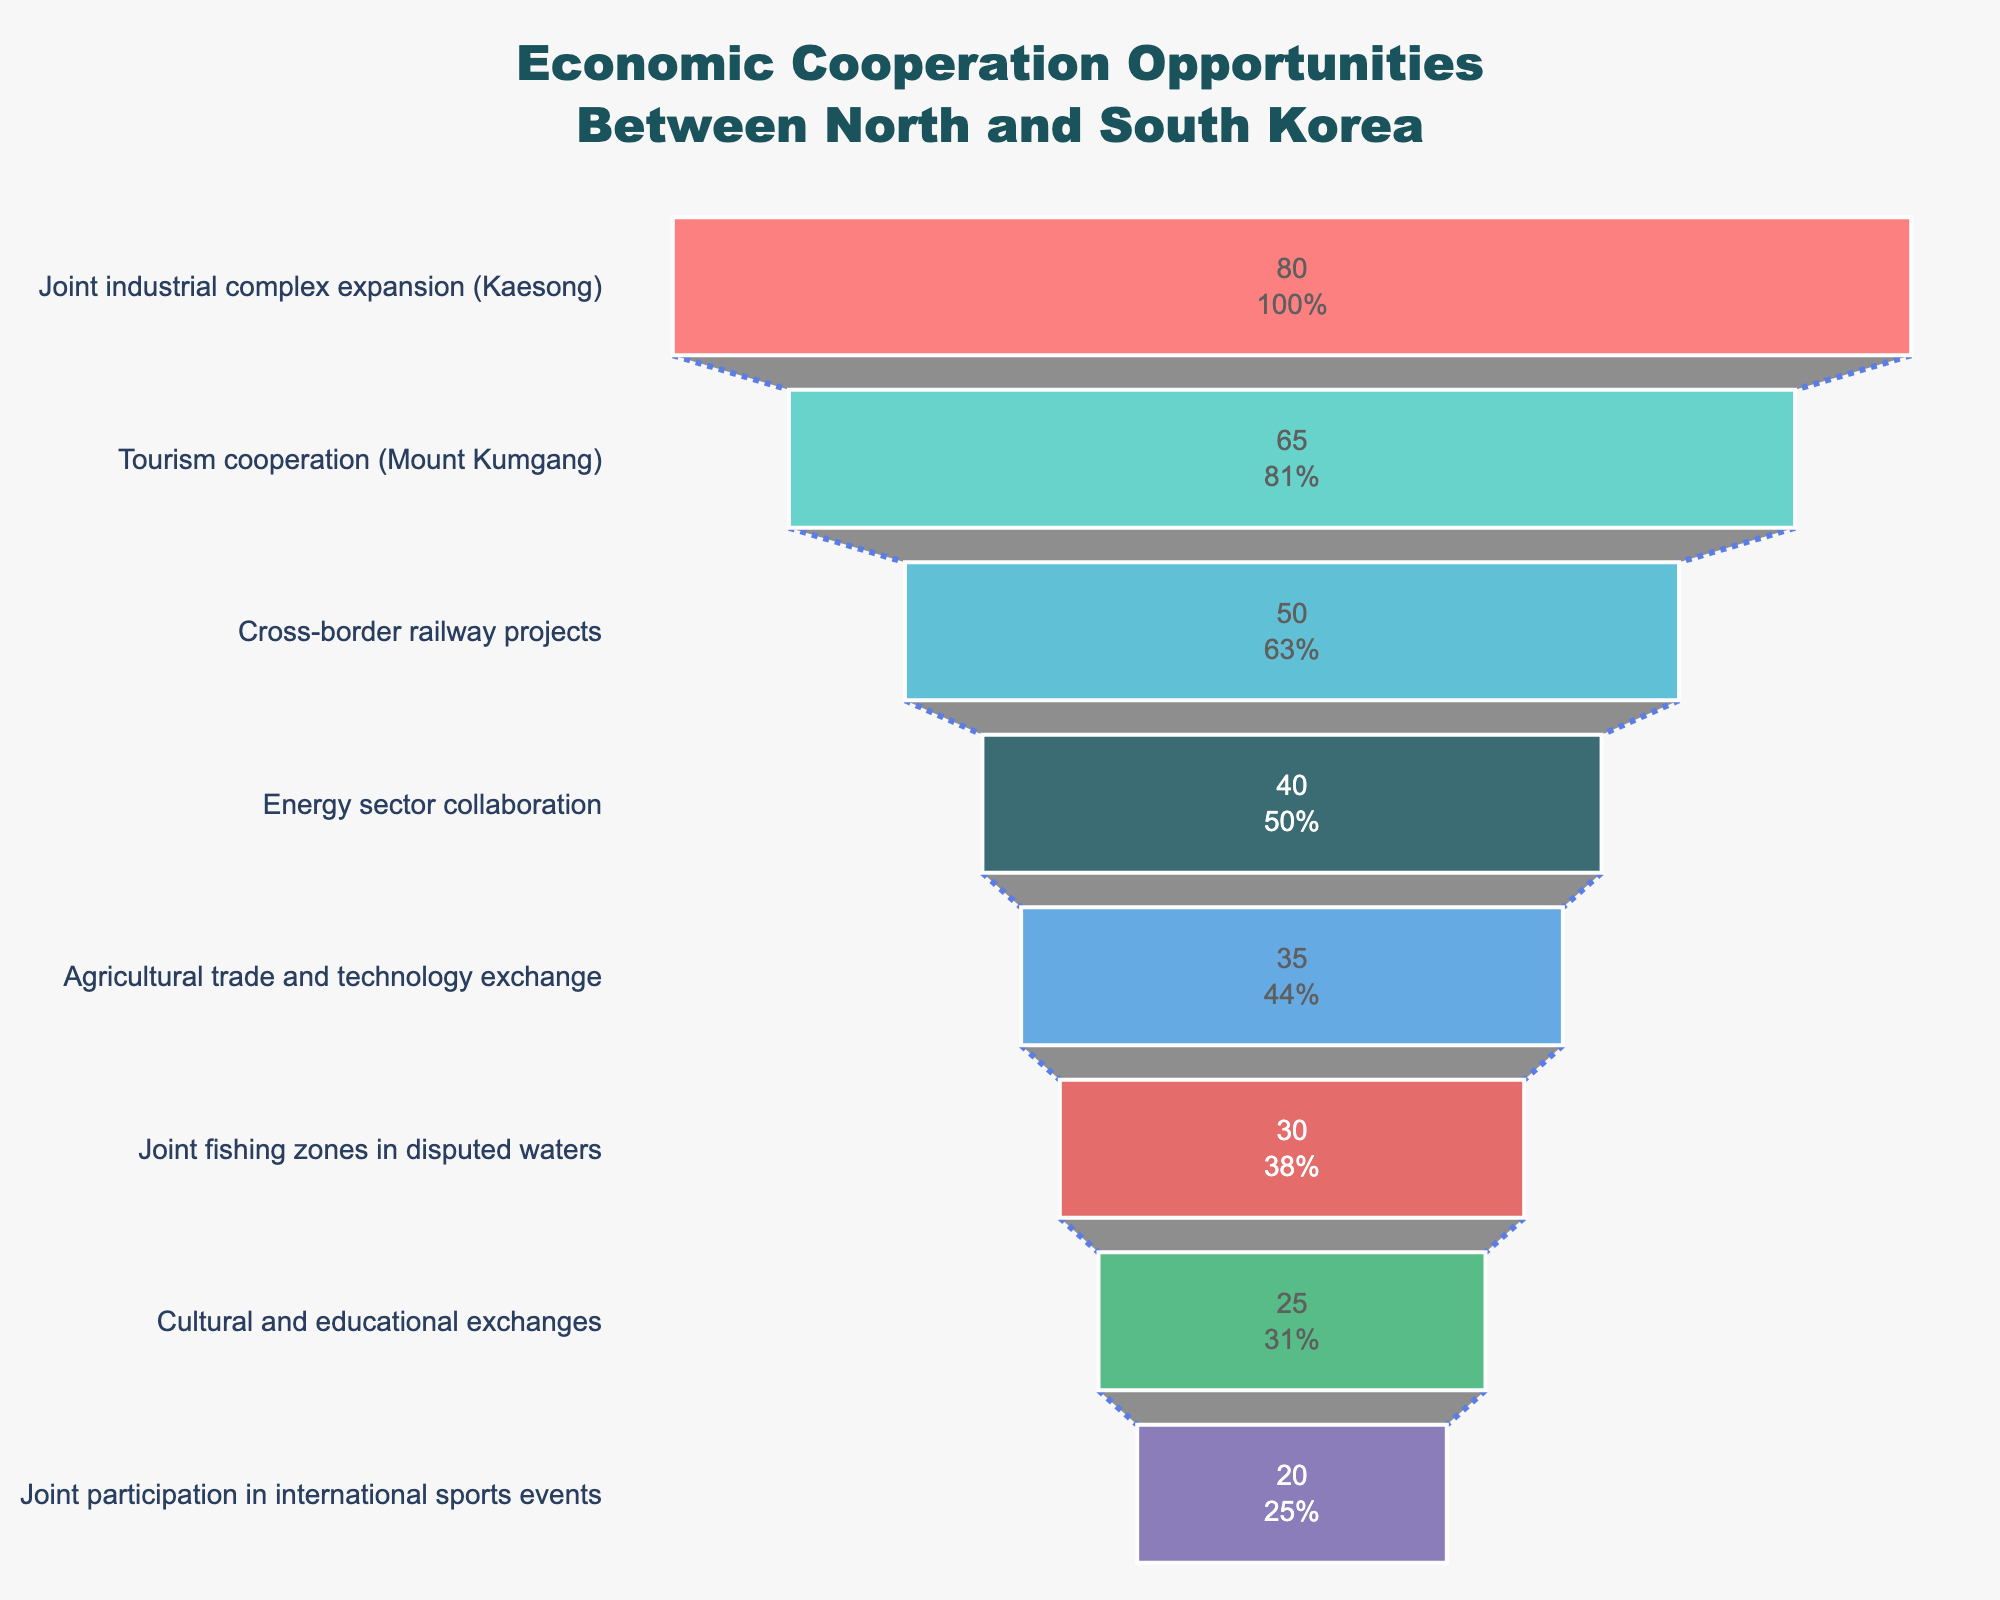What is the title of the funnel chart? The title is located at the top center of the figure, which reads "Economic Cooperation Opportunities Between North and South Korea".
Answer: Economic Cooperation Opportunities Between North and South Korea How many categories are shown in the funnel chart? By counting the unique categories listed along the vertical axis of the funnel chart, we can see there are eight categories represented.
Answer: Eight Which economic cooperation opportunity has the highest feasibility? The funnel chart lists opportunities from most to least feasible, with "Joint industrial complex expansion (Kaesong)" placed at the top, making it the one with the highest feasibility.
Answer: Joint industrial complex expansion (Kaesong) What is the feasibility percentage for Tourism cooperation (Mount Kumgang)? Checking the values listed inside the funnel chart, "Tourism cooperation (Mount Kumgang)" is marked with a feasibility percentage of 65%.
Answer: 65% What is the combined feasibility of the top three cooperation opportunities? The top three opportunities are "Joint industrial complex expansion (Kaesong)" (80), "Tourism cooperation (Mount Kumgang)" (65), and "Cross-border railway projects" (50). Summing these percentages gives 80 + 65 + 50 = 195.
Answer: 195 How does the feasibility of Cross-border railway projects compare to that of Agricultural trade and technology exchange? Comparing the feasibility percentages, "Cross-border railway projects" has a feasibility of 50%, while "Agricultural trade and technology exchange" has a feasibility of 35%. Thus, the former is more feasible.
Answer: Cross-border railway projects is more feasible What is the least feasible economic cooperation opportunity? The funnel chart's bottom most entry represents the least feasible opportunity, which is "Joint participation in international sports events" at 20%.
Answer: Joint participation in international sports events What is the average feasibility of the opportunities listed? To find the average feasibility, add all feasibility percentages and divide by the number of categories: (80 + 65 + 50 + 40 + 35 + 30 + 25 + 20) / 8 = 43.125.
Answer: 43.125 What is the percentage difference in feasibility between Energy sector collaboration and Cultural and educational exchanges? Energy sector collaboration has a feasibility of 40% and Cultural and educational exchanges have 25%. The difference is 40 - 25 = 15%.
Answer: 15% Explain the trend shown by the colors in the funnel chart. The colors change progressively from top to bottom, starting with more intense colors like red and transitioning to cooler colors like blue and purple. This indicates the change in feasibility, with more saturated colors likely representing higher feasibility.
Answer: Colors transition from intense to cool, indicating feasibility 